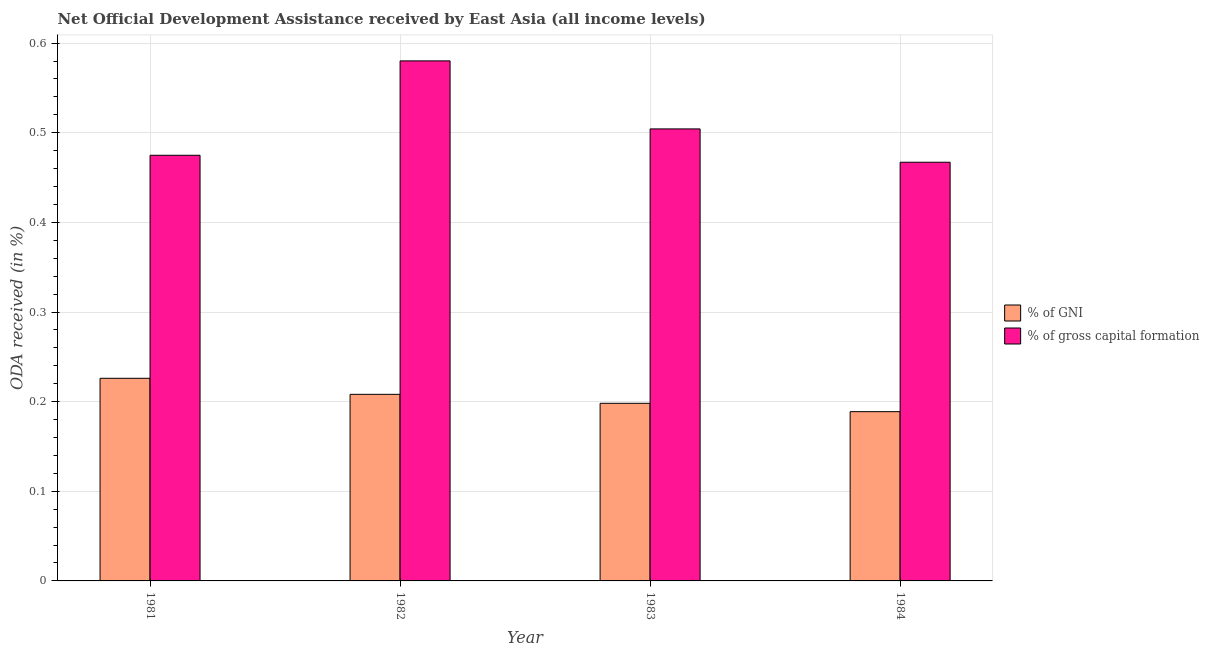Are the number of bars per tick equal to the number of legend labels?
Your answer should be very brief. Yes. How many bars are there on the 3rd tick from the right?
Offer a terse response. 2. In how many cases, is the number of bars for a given year not equal to the number of legend labels?
Ensure brevity in your answer.  0. What is the oda received as percentage of gross capital formation in 1983?
Provide a succinct answer. 0.5. Across all years, what is the maximum oda received as percentage of gross capital formation?
Ensure brevity in your answer.  0.58. Across all years, what is the minimum oda received as percentage of gni?
Provide a short and direct response. 0.19. In which year was the oda received as percentage of gni maximum?
Provide a short and direct response. 1981. In which year was the oda received as percentage of gross capital formation minimum?
Provide a short and direct response. 1984. What is the total oda received as percentage of gross capital formation in the graph?
Ensure brevity in your answer.  2.03. What is the difference between the oda received as percentage of gni in 1981 and that in 1984?
Offer a terse response. 0.04. What is the difference between the oda received as percentage of gni in 1984 and the oda received as percentage of gross capital formation in 1983?
Offer a terse response. -0.01. What is the average oda received as percentage of gni per year?
Keep it short and to the point. 0.21. What is the ratio of the oda received as percentage of gni in 1982 to that in 1984?
Offer a terse response. 1.1. Is the difference between the oda received as percentage of gni in 1981 and 1982 greater than the difference between the oda received as percentage of gross capital formation in 1981 and 1982?
Make the answer very short. No. What is the difference between the highest and the second highest oda received as percentage of gni?
Make the answer very short. 0.02. What is the difference between the highest and the lowest oda received as percentage of gni?
Your answer should be very brief. 0.04. In how many years, is the oda received as percentage of gross capital formation greater than the average oda received as percentage of gross capital formation taken over all years?
Offer a terse response. 1. What does the 2nd bar from the left in 1982 represents?
Your answer should be compact. % of gross capital formation. What does the 1st bar from the right in 1981 represents?
Offer a very short reply. % of gross capital formation. Are the values on the major ticks of Y-axis written in scientific E-notation?
Your answer should be compact. No. Does the graph contain any zero values?
Give a very brief answer. No. What is the title of the graph?
Offer a very short reply. Net Official Development Assistance received by East Asia (all income levels). What is the label or title of the X-axis?
Your answer should be compact. Year. What is the label or title of the Y-axis?
Ensure brevity in your answer.  ODA received (in %). What is the ODA received (in %) of % of GNI in 1981?
Provide a succinct answer. 0.23. What is the ODA received (in %) of % of gross capital formation in 1981?
Offer a very short reply. 0.47. What is the ODA received (in %) of % of GNI in 1982?
Provide a succinct answer. 0.21. What is the ODA received (in %) of % of gross capital formation in 1982?
Ensure brevity in your answer.  0.58. What is the ODA received (in %) of % of GNI in 1983?
Offer a terse response. 0.2. What is the ODA received (in %) in % of gross capital formation in 1983?
Make the answer very short. 0.5. What is the ODA received (in %) in % of GNI in 1984?
Keep it short and to the point. 0.19. What is the ODA received (in %) of % of gross capital formation in 1984?
Your answer should be very brief. 0.47. Across all years, what is the maximum ODA received (in %) of % of GNI?
Give a very brief answer. 0.23. Across all years, what is the maximum ODA received (in %) of % of gross capital formation?
Offer a terse response. 0.58. Across all years, what is the minimum ODA received (in %) in % of GNI?
Provide a short and direct response. 0.19. Across all years, what is the minimum ODA received (in %) in % of gross capital formation?
Give a very brief answer. 0.47. What is the total ODA received (in %) of % of GNI in the graph?
Ensure brevity in your answer.  0.82. What is the total ODA received (in %) in % of gross capital formation in the graph?
Your response must be concise. 2.03. What is the difference between the ODA received (in %) of % of GNI in 1981 and that in 1982?
Provide a short and direct response. 0.02. What is the difference between the ODA received (in %) of % of gross capital formation in 1981 and that in 1982?
Make the answer very short. -0.11. What is the difference between the ODA received (in %) in % of GNI in 1981 and that in 1983?
Offer a very short reply. 0.03. What is the difference between the ODA received (in %) of % of gross capital formation in 1981 and that in 1983?
Provide a succinct answer. -0.03. What is the difference between the ODA received (in %) in % of GNI in 1981 and that in 1984?
Offer a very short reply. 0.04. What is the difference between the ODA received (in %) of % of gross capital formation in 1981 and that in 1984?
Offer a terse response. 0.01. What is the difference between the ODA received (in %) in % of GNI in 1982 and that in 1983?
Ensure brevity in your answer.  0.01. What is the difference between the ODA received (in %) in % of gross capital formation in 1982 and that in 1983?
Keep it short and to the point. 0.08. What is the difference between the ODA received (in %) of % of GNI in 1982 and that in 1984?
Your answer should be compact. 0.02. What is the difference between the ODA received (in %) in % of gross capital formation in 1982 and that in 1984?
Your response must be concise. 0.11. What is the difference between the ODA received (in %) in % of GNI in 1983 and that in 1984?
Your response must be concise. 0.01. What is the difference between the ODA received (in %) in % of gross capital formation in 1983 and that in 1984?
Make the answer very short. 0.04. What is the difference between the ODA received (in %) in % of GNI in 1981 and the ODA received (in %) in % of gross capital formation in 1982?
Offer a terse response. -0.35. What is the difference between the ODA received (in %) of % of GNI in 1981 and the ODA received (in %) of % of gross capital formation in 1983?
Provide a short and direct response. -0.28. What is the difference between the ODA received (in %) in % of GNI in 1981 and the ODA received (in %) in % of gross capital formation in 1984?
Provide a short and direct response. -0.24. What is the difference between the ODA received (in %) in % of GNI in 1982 and the ODA received (in %) in % of gross capital formation in 1983?
Your answer should be very brief. -0.3. What is the difference between the ODA received (in %) in % of GNI in 1982 and the ODA received (in %) in % of gross capital formation in 1984?
Your response must be concise. -0.26. What is the difference between the ODA received (in %) of % of GNI in 1983 and the ODA received (in %) of % of gross capital formation in 1984?
Your answer should be very brief. -0.27. What is the average ODA received (in %) of % of GNI per year?
Give a very brief answer. 0.21. What is the average ODA received (in %) of % of gross capital formation per year?
Your answer should be compact. 0.51. In the year 1981, what is the difference between the ODA received (in %) in % of GNI and ODA received (in %) in % of gross capital formation?
Give a very brief answer. -0.25. In the year 1982, what is the difference between the ODA received (in %) of % of GNI and ODA received (in %) of % of gross capital formation?
Your response must be concise. -0.37. In the year 1983, what is the difference between the ODA received (in %) of % of GNI and ODA received (in %) of % of gross capital formation?
Your answer should be compact. -0.31. In the year 1984, what is the difference between the ODA received (in %) in % of GNI and ODA received (in %) in % of gross capital formation?
Ensure brevity in your answer.  -0.28. What is the ratio of the ODA received (in %) of % of GNI in 1981 to that in 1982?
Provide a succinct answer. 1.09. What is the ratio of the ODA received (in %) in % of gross capital formation in 1981 to that in 1982?
Your answer should be compact. 0.82. What is the ratio of the ODA received (in %) of % of GNI in 1981 to that in 1983?
Keep it short and to the point. 1.14. What is the ratio of the ODA received (in %) of % of gross capital formation in 1981 to that in 1983?
Offer a terse response. 0.94. What is the ratio of the ODA received (in %) in % of GNI in 1981 to that in 1984?
Your response must be concise. 1.2. What is the ratio of the ODA received (in %) in % of gross capital formation in 1981 to that in 1984?
Give a very brief answer. 1.02. What is the ratio of the ODA received (in %) of % of GNI in 1982 to that in 1983?
Offer a terse response. 1.05. What is the ratio of the ODA received (in %) in % of gross capital formation in 1982 to that in 1983?
Provide a succinct answer. 1.15. What is the ratio of the ODA received (in %) of % of GNI in 1982 to that in 1984?
Give a very brief answer. 1.1. What is the ratio of the ODA received (in %) of % of gross capital formation in 1982 to that in 1984?
Give a very brief answer. 1.24. What is the ratio of the ODA received (in %) in % of GNI in 1983 to that in 1984?
Keep it short and to the point. 1.05. What is the ratio of the ODA received (in %) in % of gross capital formation in 1983 to that in 1984?
Your response must be concise. 1.08. What is the difference between the highest and the second highest ODA received (in %) of % of GNI?
Keep it short and to the point. 0.02. What is the difference between the highest and the second highest ODA received (in %) in % of gross capital formation?
Provide a short and direct response. 0.08. What is the difference between the highest and the lowest ODA received (in %) of % of GNI?
Your answer should be compact. 0.04. What is the difference between the highest and the lowest ODA received (in %) of % of gross capital formation?
Offer a terse response. 0.11. 